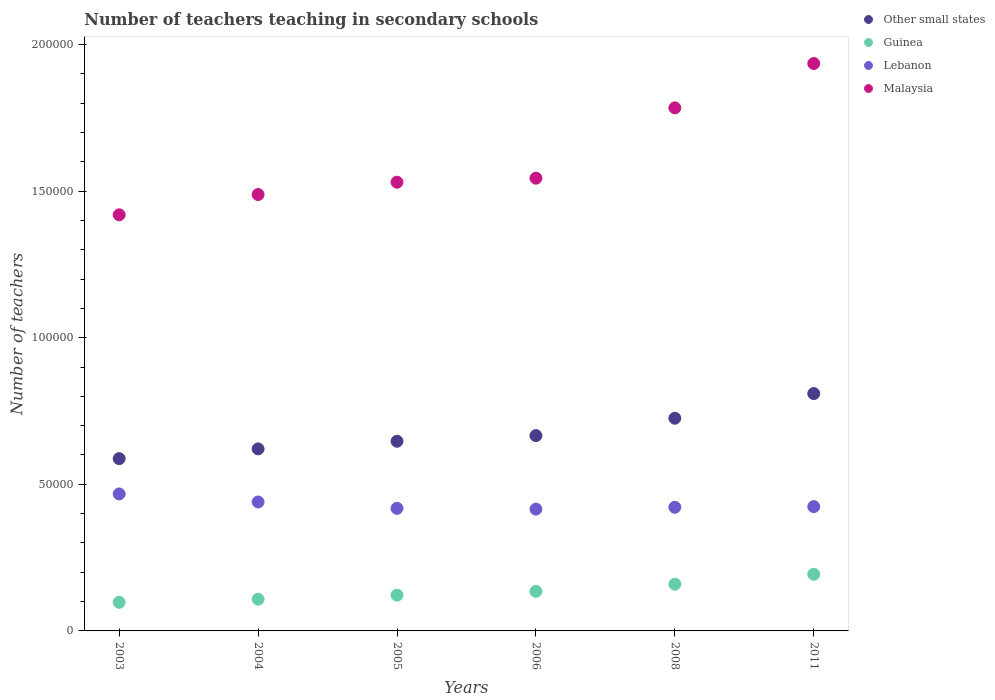How many different coloured dotlines are there?
Offer a very short reply. 4. Is the number of dotlines equal to the number of legend labels?
Offer a very short reply. Yes. What is the number of teachers teaching in secondary schools in Guinea in 2008?
Provide a succinct answer. 1.59e+04. Across all years, what is the maximum number of teachers teaching in secondary schools in Lebanon?
Give a very brief answer. 4.67e+04. Across all years, what is the minimum number of teachers teaching in secondary schools in Malaysia?
Provide a short and direct response. 1.42e+05. In which year was the number of teachers teaching in secondary schools in Guinea minimum?
Offer a terse response. 2003. What is the total number of teachers teaching in secondary schools in Guinea in the graph?
Provide a succinct answer. 8.15e+04. What is the difference between the number of teachers teaching in secondary schools in Guinea in 2003 and that in 2005?
Give a very brief answer. -2445. What is the difference between the number of teachers teaching in secondary schools in Lebanon in 2006 and the number of teachers teaching in secondary schools in Malaysia in 2004?
Offer a very short reply. -1.07e+05. What is the average number of teachers teaching in secondary schools in Malaysia per year?
Offer a very short reply. 1.62e+05. In the year 2005, what is the difference between the number of teachers teaching in secondary schools in Guinea and number of teachers teaching in secondary schools in Other small states?
Your response must be concise. -5.25e+04. In how many years, is the number of teachers teaching in secondary schools in Guinea greater than 40000?
Provide a succinct answer. 0. What is the ratio of the number of teachers teaching in secondary schools in Other small states in 2004 to that in 2008?
Your answer should be compact. 0.86. Is the number of teachers teaching in secondary schools in Lebanon in 2005 less than that in 2011?
Provide a succinct answer. Yes. Is the difference between the number of teachers teaching in secondary schools in Guinea in 2005 and 2006 greater than the difference between the number of teachers teaching in secondary schools in Other small states in 2005 and 2006?
Keep it short and to the point. Yes. What is the difference between the highest and the second highest number of teachers teaching in secondary schools in Guinea?
Keep it short and to the point. 3381. What is the difference between the highest and the lowest number of teachers teaching in secondary schools in Other small states?
Keep it short and to the point. 2.22e+04. In how many years, is the number of teachers teaching in secondary schools in Guinea greater than the average number of teachers teaching in secondary schools in Guinea taken over all years?
Your answer should be very brief. 2. Is the number of teachers teaching in secondary schools in Malaysia strictly greater than the number of teachers teaching in secondary schools in Other small states over the years?
Offer a terse response. Yes. Is the number of teachers teaching in secondary schools in Lebanon strictly less than the number of teachers teaching in secondary schools in Other small states over the years?
Your answer should be compact. Yes. Does the graph contain any zero values?
Provide a short and direct response. No. How are the legend labels stacked?
Your response must be concise. Vertical. What is the title of the graph?
Your answer should be very brief. Number of teachers teaching in secondary schools. What is the label or title of the X-axis?
Ensure brevity in your answer.  Years. What is the label or title of the Y-axis?
Ensure brevity in your answer.  Number of teachers. What is the Number of teachers of Other small states in 2003?
Keep it short and to the point. 5.88e+04. What is the Number of teachers in Guinea in 2003?
Ensure brevity in your answer.  9757. What is the Number of teachers of Lebanon in 2003?
Give a very brief answer. 4.67e+04. What is the Number of teachers of Malaysia in 2003?
Keep it short and to the point. 1.42e+05. What is the Number of teachers of Other small states in 2004?
Offer a terse response. 6.21e+04. What is the Number of teachers of Guinea in 2004?
Keep it short and to the point. 1.08e+04. What is the Number of teachers of Lebanon in 2004?
Ensure brevity in your answer.  4.40e+04. What is the Number of teachers of Malaysia in 2004?
Offer a terse response. 1.49e+05. What is the Number of teachers in Other small states in 2005?
Ensure brevity in your answer.  6.47e+04. What is the Number of teachers of Guinea in 2005?
Give a very brief answer. 1.22e+04. What is the Number of teachers in Lebanon in 2005?
Your answer should be compact. 4.18e+04. What is the Number of teachers of Malaysia in 2005?
Ensure brevity in your answer.  1.53e+05. What is the Number of teachers of Other small states in 2006?
Make the answer very short. 6.66e+04. What is the Number of teachers of Guinea in 2006?
Give a very brief answer. 1.35e+04. What is the Number of teachers of Lebanon in 2006?
Ensure brevity in your answer.  4.15e+04. What is the Number of teachers of Malaysia in 2006?
Make the answer very short. 1.54e+05. What is the Number of teachers of Other small states in 2008?
Provide a short and direct response. 7.25e+04. What is the Number of teachers of Guinea in 2008?
Make the answer very short. 1.59e+04. What is the Number of teachers in Lebanon in 2008?
Make the answer very short. 4.22e+04. What is the Number of teachers of Malaysia in 2008?
Make the answer very short. 1.78e+05. What is the Number of teachers of Other small states in 2011?
Provide a succinct answer. 8.09e+04. What is the Number of teachers of Guinea in 2011?
Your answer should be very brief. 1.93e+04. What is the Number of teachers in Lebanon in 2011?
Offer a terse response. 4.24e+04. What is the Number of teachers of Malaysia in 2011?
Provide a short and direct response. 1.94e+05. Across all years, what is the maximum Number of teachers of Other small states?
Make the answer very short. 8.09e+04. Across all years, what is the maximum Number of teachers in Guinea?
Give a very brief answer. 1.93e+04. Across all years, what is the maximum Number of teachers in Lebanon?
Your response must be concise. 4.67e+04. Across all years, what is the maximum Number of teachers of Malaysia?
Your answer should be compact. 1.94e+05. Across all years, what is the minimum Number of teachers in Other small states?
Offer a terse response. 5.88e+04. Across all years, what is the minimum Number of teachers in Guinea?
Your answer should be very brief. 9757. Across all years, what is the minimum Number of teachers in Lebanon?
Ensure brevity in your answer.  4.15e+04. Across all years, what is the minimum Number of teachers in Malaysia?
Keep it short and to the point. 1.42e+05. What is the total Number of teachers in Other small states in the graph?
Give a very brief answer. 4.06e+05. What is the total Number of teachers in Guinea in the graph?
Your answer should be very brief. 8.15e+04. What is the total Number of teachers in Lebanon in the graph?
Keep it short and to the point. 2.59e+05. What is the total Number of teachers in Malaysia in the graph?
Give a very brief answer. 9.70e+05. What is the difference between the Number of teachers of Other small states in 2003 and that in 2004?
Offer a very short reply. -3322.16. What is the difference between the Number of teachers of Guinea in 2003 and that in 2004?
Keep it short and to the point. -1071. What is the difference between the Number of teachers of Lebanon in 2003 and that in 2004?
Provide a short and direct response. 2750. What is the difference between the Number of teachers in Malaysia in 2003 and that in 2004?
Your answer should be compact. -6911. What is the difference between the Number of teachers of Other small states in 2003 and that in 2005?
Ensure brevity in your answer.  -5920.92. What is the difference between the Number of teachers in Guinea in 2003 and that in 2005?
Your answer should be very brief. -2445. What is the difference between the Number of teachers of Lebanon in 2003 and that in 2005?
Provide a short and direct response. 4920. What is the difference between the Number of teachers of Malaysia in 2003 and that in 2005?
Keep it short and to the point. -1.11e+04. What is the difference between the Number of teachers in Other small states in 2003 and that in 2006?
Keep it short and to the point. -7842.73. What is the difference between the Number of teachers of Guinea in 2003 and that in 2006?
Give a very brief answer. -3720. What is the difference between the Number of teachers of Lebanon in 2003 and that in 2006?
Your answer should be compact. 5185. What is the difference between the Number of teachers of Malaysia in 2003 and that in 2006?
Provide a succinct answer. -1.25e+04. What is the difference between the Number of teachers in Other small states in 2003 and that in 2008?
Offer a very short reply. -1.38e+04. What is the difference between the Number of teachers in Guinea in 2003 and that in 2008?
Keep it short and to the point. -6184. What is the difference between the Number of teachers of Lebanon in 2003 and that in 2008?
Provide a short and direct response. 4556. What is the difference between the Number of teachers in Malaysia in 2003 and that in 2008?
Your answer should be compact. -3.65e+04. What is the difference between the Number of teachers of Other small states in 2003 and that in 2011?
Offer a terse response. -2.22e+04. What is the difference between the Number of teachers in Guinea in 2003 and that in 2011?
Keep it short and to the point. -9565. What is the difference between the Number of teachers in Lebanon in 2003 and that in 2011?
Your answer should be very brief. 4334. What is the difference between the Number of teachers in Malaysia in 2003 and that in 2011?
Offer a terse response. -5.16e+04. What is the difference between the Number of teachers of Other small states in 2004 and that in 2005?
Your response must be concise. -2598.76. What is the difference between the Number of teachers of Guinea in 2004 and that in 2005?
Give a very brief answer. -1374. What is the difference between the Number of teachers in Lebanon in 2004 and that in 2005?
Provide a short and direct response. 2170. What is the difference between the Number of teachers in Malaysia in 2004 and that in 2005?
Make the answer very short. -4207. What is the difference between the Number of teachers in Other small states in 2004 and that in 2006?
Offer a terse response. -4520.57. What is the difference between the Number of teachers of Guinea in 2004 and that in 2006?
Make the answer very short. -2649. What is the difference between the Number of teachers of Lebanon in 2004 and that in 2006?
Your response must be concise. 2435. What is the difference between the Number of teachers in Malaysia in 2004 and that in 2006?
Offer a very short reply. -5583. What is the difference between the Number of teachers in Other small states in 2004 and that in 2008?
Give a very brief answer. -1.05e+04. What is the difference between the Number of teachers in Guinea in 2004 and that in 2008?
Keep it short and to the point. -5113. What is the difference between the Number of teachers of Lebanon in 2004 and that in 2008?
Offer a terse response. 1806. What is the difference between the Number of teachers in Malaysia in 2004 and that in 2008?
Offer a terse response. -2.96e+04. What is the difference between the Number of teachers of Other small states in 2004 and that in 2011?
Your answer should be compact. -1.89e+04. What is the difference between the Number of teachers in Guinea in 2004 and that in 2011?
Your answer should be very brief. -8494. What is the difference between the Number of teachers of Lebanon in 2004 and that in 2011?
Offer a very short reply. 1584. What is the difference between the Number of teachers of Malaysia in 2004 and that in 2011?
Give a very brief answer. -4.47e+04. What is the difference between the Number of teachers in Other small states in 2005 and that in 2006?
Offer a very short reply. -1921.81. What is the difference between the Number of teachers in Guinea in 2005 and that in 2006?
Your answer should be very brief. -1275. What is the difference between the Number of teachers of Lebanon in 2005 and that in 2006?
Offer a terse response. 265. What is the difference between the Number of teachers of Malaysia in 2005 and that in 2006?
Offer a terse response. -1376. What is the difference between the Number of teachers in Other small states in 2005 and that in 2008?
Offer a terse response. -7857.45. What is the difference between the Number of teachers in Guinea in 2005 and that in 2008?
Provide a succinct answer. -3739. What is the difference between the Number of teachers of Lebanon in 2005 and that in 2008?
Offer a very short reply. -364. What is the difference between the Number of teachers of Malaysia in 2005 and that in 2008?
Your answer should be very brief. -2.53e+04. What is the difference between the Number of teachers of Other small states in 2005 and that in 2011?
Your answer should be very brief. -1.63e+04. What is the difference between the Number of teachers in Guinea in 2005 and that in 2011?
Your response must be concise. -7120. What is the difference between the Number of teachers in Lebanon in 2005 and that in 2011?
Offer a terse response. -586. What is the difference between the Number of teachers of Malaysia in 2005 and that in 2011?
Ensure brevity in your answer.  -4.05e+04. What is the difference between the Number of teachers in Other small states in 2006 and that in 2008?
Make the answer very short. -5935.64. What is the difference between the Number of teachers of Guinea in 2006 and that in 2008?
Give a very brief answer. -2464. What is the difference between the Number of teachers of Lebanon in 2006 and that in 2008?
Give a very brief answer. -629. What is the difference between the Number of teachers in Malaysia in 2006 and that in 2008?
Make the answer very short. -2.40e+04. What is the difference between the Number of teachers in Other small states in 2006 and that in 2011?
Make the answer very short. -1.43e+04. What is the difference between the Number of teachers of Guinea in 2006 and that in 2011?
Offer a very short reply. -5845. What is the difference between the Number of teachers of Lebanon in 2006 and that in 2011?
Offer a very short reply. -851. What is the difference between the Number of teachers of Malaysia in 2006 and that in 2011?
Make the answer very short. -3.91e+04. What is the difference between the Number of teachers in Other small states in 2008 and that in 2011?
Make the answer very short. -8408.55. What is the difference between the Number of teachers in Guinea in 2008 and that in 2011?
Provide a succinct answer. -3381. What is the difference between the Number of teachers of Lebanon in 2008 and that in 2011?
Keep it short and to the point. -222. What is the difference between the Number of teachers of Malaysia in 2008 and that in 2011?
Provide a succinct answer. -1.51e+04. What is the difference between the Number of teachers of Other small states in 2003 and the Number of teachers of Guinea in 2004?
Provide a succinct answer. 4.79e+04. What is the difference between the Number of teachers in Other small states in 2003 and the Number of teachers in Lebanon in 2004?
Keep it short and to the point. 1.48e+04. What is the difference between the Number of teachers in Other small states in 2003 and the Number of teachers in Malaysia in 2004?
Make the answer very short. -9.01e+04. What is the difference between the Number of teachers of Guinea in 2003 and the Number of teachers of Lebanon in 2004?
Offer a terse response. -3.42e+04. What is the difference between the Number of teachers in Guinea in 2003 and the Number of teachers in Malaysia in 2004?
Ensure brevity in your answer.  -1.39e+05. What is the difference between the Number of teachers of Lebanon in 2003 and the Number of teachers of Malaysia in 2004?
Your response must be concise. -1.02e+05. What is the difference between the Number of teachers in Other small states in 2003 and the Number of teachers in Guinea in 2005?
Ensure brevity in your answer.  4.66e+04. What is the difference between the Number of teachers in Other small states in 2003 and the Number of teachers in Lebanon in 2005?
Offer a very short reply. 1.70e+04. What is the difference between the Number of teachers in Other small states in 2003 and the Number of teachers in Malaysia in 2005?
Your answer should be very brief. -9.43e+04. What is the difference between the Number of teachers of Guinea in 2003 and the Number of teachers of Lebanon in 2005?
Ensure brevity in your answer.  -3.20e+04. What is the difference between the Number of teachers in Guinea in 2003 and the Number of teachers in Malaysia in 2005?
Provide a short and direct response. -1.43e+05. What is the difference between the Number of teachers of Lebanon in 2003 and the Number of teachers of Malaysia in 2005?
Your answer should be compact. -1.06e+05. What is the difference between the Number of teachers of Other small states in 2003 and the Number of teachers of Guinea in 2006?
Keep it short and to the point. 4.53e+04. What is the difference between the Number of teachers in Other small states in 2003 and the Number of teachers in Lebanon in 2006?
Give a very brief answer. 1.72e+04. What is the difference between the Number of teachers of Other small states in 2003 and the Number of teachers of Malaysia in 2006?
Offer a very short reply. -9.56e+04. What is the difference between the Number of teachers of Guinea in 2003 and the Number of teachers of Lebanon in 2006?
Your answer should be very brief. -3.18e+04. What is the difference between the Number of teachers in Guinea in 2003 and the Number of teachers in Malaysia in 2006?
Offer a terse response. -1.45e+05. What is the difference between the Number of teachers of Lebanon in 2003 and the Number of teachers of Malaysia in 2006?
Offer a very short reply. -1.08e+05. What is the difference between the Number of teachers of Other small states in 2003 and the Number of teachers of Guinea in 2008?
Make the answer very short. 4.28e+04. What is the difference between the Number of teachers in Other small states in 2003 and the Number of teachers in Lebanon in 2008?
Your answer should be very brief. 1.66e+04. What is the difference between the Number of teachers of Other small states in 2003 and the Number of teachers of Malaysia in 2008?
Your answer should be very brief. -1.20e+05. What is the difference between the Number of teachers in Guinea in 2003 and the Number of teachers in Lebanon in 2008?
Offer a terse response. -3.24e+04. What is the difference between the Number of teachers in Guinea in 2003 and the Number of teachers in Malaysia in 2008?
Your response must be concise. -1.69e+05. What is the difference between the Number of teachers in Lebanon in 2003 and the Number of teachers in Malaysia in 2008?
Give a very brief answer. -1.32e+05. What is the difference between the Number of teachers of Other small states in 2003 and the Number of teachers of Guinea in 2011?
Your answer should be compact. 3.94e+04. What is the difference between the Number of teachers of Other small states in 2003 and the Number of teachers of Lebanon in 2011?
Offer a very short reply. 1.64e+04. What is the difference between the Number of teachers in Other small states in 2003 and the Number of teachers in Malaysia in 2011?
Ensure brevity in your answer.  -1.35e+05. What is the difference between the Number of teachers in Guinea in 2003 and the Number of teachers in Lebanon in 2011?
Your response must be concise. -3.26e+04. What is the difference between the Number of teachers in Guinea in 2003 and the Number of teachers in Malaysia in 2011?
Make the answer very short. -1.84e+05. What is the difference between the Number of teachers of Lebanon in 2003 and the Number of teachers of Malaysia in 2011?
Give a very brief answer. -1.47e+05. What is the difference between the Number of teachers in Other small states in 2004 and the Number of teachers in Guinea in 2005?
Your response must be concise. 4.99e+04. What is the difference between the Number of teachers of Other small states in 2004 and the Number of teachers of Lebanon in 2005?
Offer a very short reply. 2.03e+04. What is the difference between the Number of teachers in Other small states in 2004 and the Number of teachers in Malaysia in 2005?
Your response must be concise. -9.10e+04. What is the difference between the Number of teachers of Guinea in 2004 and the Number of teachers of Lebanon in 2005?
Give a very brief answer. -3.10e+04. What is the difference between the Number of teachers of Guinea in 2004 and the Number of teachers of Malaysia in 2005?
Provide a succinct answer. -1.42e+05. What is the difference between the Number of teachers of Lebanon in 2004 and the Number of teachers of Malaysia in 2005?
Make the answer very short. -1.09e+05. What is the difference between the Number of teachers in Other small states in 2004 and the Number of teachers in Guinea in 2006?
Offer a very short reply. 4.86e+04. What is the difference between the Number of teachers of Other small states in 2004 and the Number of teachers of Lebanon in 2006?
Offer a terse response. 2.05e+04. What is the difference between the Number of teachers of Other small states in 2004 and the Number of teachers of Malaysia in 2006?
Make the answer very short. -9.23e+04. What is the difference between the Number of teachers of Guinea in 2004 and the Number of teachers of Lebanon in 2006?
Provide a succinct answer. -3.07e+04. What is the difference between the Number of teachers in Guinea in 2004 and the Number of teachers in Malaysia in 2006?
Offer a terse response. -1.44e+05. What is the difference between the Number of teachers of Lebanon in 2004 and the Number of teachers of Malaysia in 2006?
Your response must be concise. -1.10e+05. What is the difference between the Number of teachers in Other small states in 2004 and the Number of teachers in Guinea in 2008?
Ensure brevity in your answer.  4.61e+04. What is the difference between the Number of teachers of Other small states in 2004 and the Number of teachers of Lebanon in 2008?
Offer a terse response. 1.99e+04. What is the difference between the Number of teachers in Other small states in 2004 and the Number of teachers in Malaysia in 2008?
Make the answer very short. -1.16e+05. What is the difference between the Number of teachers in Guinea in 2004 and the Number of teachers in Lebanon in 2008?
Ensure brevity in your answer.  -3.13e+04. What is the difference between the Number of teachers in Guinea in 2004 and the Number of teachers in Malaysia in 2008?
Provide a succinct answer. -1.68e+05. What is the difference between the Number of teachers of Lebanon in 2004 and the Number of teachers of Malaysia in 2008?
Offer a very short reply. -1.34e+05. What is the difference between the Number of teachers of Other small states in 2004 and the Number of teachers of Guinea in 2011?
Your answer should be very brief. 4.28e+04. What is the difference between the Number of teachers in Other small states in 2004 and the Number of teachers in Lebanon in 2011?
Your answer should be compact. 1.97e+04. What is the difference between the Number of teachers of Other small states in 2004 and the Number of teachers of Malaysia in 2011?
Provide a short and direct response. -1.31e+05. What is the difference between the Number of teachers in Guinea in 2004 and the Number of teachers in Lebanon in 2011?
Keep it short and to the point. -3.16e+04. What is the difference between the Number of teachers in Guinea in 2004 and the Number of teachers in Malaysia in 2011?
Provide a succinct answer. -1.83e+05. What is the difference between the Number of teachers in Lebanon in 2004 and the Number of teachers in Malaysia in 2011?
Make the answer very short. -1.50e+05. What is the difference between the Number of teachers in Other small states in 2005 and the Number of teachers in Guinea in 2006?
Offer a very short reply. 5.12e+04. What is the difference between the Number of teachers of Other small states in 2005 and the Number of teachers of Lebanon in 2006?
Keep it short and to the point. 2.31e+04. What is the difference between the Number of teachers in Other small states in 2005 and the Number of teachers in Malaysia in 2006?
Provide a succinct answer. -8.97e+04. What is the difference between the Number of teachers of Guinea in 2005 and the Number of teachers of Lebanon in 2006?
Your answer should be compact. -2.93e+04. What is the difference between the Number of teachers of Guinea in 2005 and the Number of teachers of Malaysia in 2006?
Provide a succinct answer. -1.42e+05. What is the difference between the Number of teachers in Lebanon in 2005 and the Number of teachers in Malaysia in 2006?
Your response must be concise. -1.13e+05. What is the difference between the Number of teachers in Other small states in 2005 and the Number of teachers in Guinea in 2008?
Offer a terse response. 4.87e+04. What is the difference between the Number of teachers of Other small states in 2005 and the Number of teachers of Lebanon in 2008?
Keep it short and to the point. 2.25e+04. What is the difference between the Number of teachers of Other small states in 2005 and the Number of teachers of Malaysia in 2008?
Offer a terse response. -1.14e+05. What is the difference between the Number of teachers of Guinea in 2005 and the Number of teachers of Lebanon in 2008?
Keep it short and to the point. -3.00e+04. What is the difference between the Number of teachers of Guinea in 2005 and the Number of teachers of Malaysia in 2008?
Your response must be concise. -1.66e+05. What is the difference between the Number of teachers of Lebanon in 2005 and the Number of teachers of Malaysia in 2008?
Your response must be concise. -1.37e+05. What is the difference between the Number of teachers in Other small states in 2005 and the Number of teachers in Guinea in 2011?
Your answer should be very brief. 4.54e+04. What is the difference between the Number of teachers of Other small states in 2005 and the Number of teachers of Lebanon in 2011?
Provide a succinct answer. 2.23e+04. What is the difference between the Number of teachers in Other small states in 2005 and the Number of teachers in Malaysia in 2011?
Your answer should be compact. -1.29e+05. What is the difference between the Number of teachers of Guinea in 2005 and the Number of teachers of Lebanon in 2011?
Keep it short and to the point. -3.02e+04. What is the difference between the Number of teachers in Guinea in 2005 and the Number of teachers in Malaysia in 2011?
Offer a terse response. -1.81e+05. What is the difference between the Number of teachers of Lebanon in 2005 and the Number of teachers of Malaysia in 2011?
Provide a succinct answer. -1.52e+05. What is the difference between the Number of teachers in Other small states in 2006 and the Number of teachers in Guinea in 2008?
Make the answer very short. 5.07e+04. What is the difference between the Number of teachers of Other small states in 2006 and the Number of teachers of Lebanon in 2008?
Provide a succinct answer. 2.44e+04. What is the difference between the Number of teachers of Other small states in 2006 and the Number of teachers of Malaysia in 2008?
Provide a short and direct response. -1.12e+05. What is the difference between the Number of teachers in Guinea in 2006 and the Number of teachers in Lebanon in 2008?
Offer a terse response. -2.87e+04. What is the difference between the Number of teachers of Guinea in 2006 and the Number of teachers of Malaysia in 2008?
Offer a terse response. -1.65e+05. What is the difference between the Number of teachers of Lebanon in 2006 and the Number of teachers of Malaysia in 2008?
Keep it short and to the point. -1.37e+05. What is the difference between the Number of teachers of Other small states in 2006 and the Number of teachers of Guinea in 2011?
Ensure brevity in your answer.  4.73e+04. What is the difference between the Number of teachers in Other small states in 2006 and the Number of teachers in Lebanon in 2011?
Keep it short and to the point. 2.42e+04. What is the difference between the Number of teachers of Other small states in 2006 and the Number of teachers of Malaysia in 2011?
Offer a terse response. -1.27e+05. What is the difference between the Number of teachers in Guinea in 2006 and the Number of teachers in Lebanon in 2011?
Make the answer very short. -2.89e+04. What is the difference between the Number of teachers of Guinea in 2006 and the Number of teachers of Malaysia in 2011?
Your response must be concise. -1.80e+05. What is the difference between the Number of teachers in Lebanon in 2006 and the Number of teachers in Malaysia in 2011?
Your response must be concise. -1.52e+05. What is the difference between the Number of teachers in Other small states in 2008 and the Number of teachers in Guinea in 2011?
Offer a terse response. 5.32e+04. What is the difference between the Number of teachers of Other small states in 2008 and the Number of teachers of Lebanon in 2011?
Ensure brevity in your answer.  3.01e+04. What is the difference between the Number of teachers of Other small states in 2008 and the Number of teachers of Malaysia in 2011?
Offer a very short reply. -1.21e+05. What is the difference between the Number of teachers of Guinea in 2008 and the Number of teachers of Lebanon in 2011?
Offer a terse response. -2.64e+04. What is the difference between the Number of teachers of Guinea in 2008 and the Number of teachers of Malaysia in 2011?
Keep it short and to the point. -1.78e+05. What is the difference between the Number of teachers of Lebanon in 2008 and the Number of teachers of Malaysia in 2011?
Provide a succinct answer. -1.51e+05. What is the average Number of teachers of Other small states per year?
Provide a short and direct response. 6.76e+04. What is the average Number of teachers in Guinea per year?
Offer a terse response. 1.36e+04. What is the average Number of teachers in Lebanon per year?
Make the answer very short. 4.31e+04. What is the average Number of teachers in Malaysia per year?
Keep it short and to the point. 1.62e+05. In the year 2003, what is the difference between the Number of teachers in Other small states and Number of teachers in Guinea?
Give a very brief answer. 4.90e+04. In the year 2003, what is the difference between the Number of teachers in Other small states and Number of teachers in Lebanon?
Provide a succinct answer. 1.20e+04. In the year 2003, what is the difference between the Number of teachers of Other small states and Number of teachers of Malaysia?
Provide a succinct answer. -8.32e+04. In the year 2003, what is the difference between the Number of teachers in Guinea and Number of teachers in Lebanon?
Offer a very short reply. -3.70e+04. In the year 2003, what is the difference between the Number of teachers of Guinea and Number of teachers of Malaysia?
Provide a short and direct response. -1.32e+05. In the year 2003, what is the difference between the Number of teachers in Lebanon and Number of teachers in Malaysia?
Make the answer very short. -9.52e+04. In the year 2004, what is the difference between the Number of teachers of Other small states and Number of teachers of Guinea?
Provide a short and direct response. 5.13e+04. In the year 2004, what is the difference between the Number of teachers in Other small states and Number of teachers in Lebanon?
Keep it short and to the point. 1.81e+04. In the year 2004, what is the difference between the Number of teachers in Other small states and Number of teachers in Malaysia?
Your response must be concise. -8.67e+04. In the year 2004, what is the difference between the Number of teachers of Guinea and Number of teachers of Lebanon?
Give a very brief answer. -3.31e+04. In the year 2004, what is the difference between the Number of teachers of Guinea and Number of teachers of Malaysia?
Keep it short and to the point. -1.38e+05. In the year 2004, what is the difference between the Number of teachers of Lebanon and Number of teachers of Malaysia?
Provide a succinct answer. -1.05e+05. In the year 2005, what is the difference between the Number of teachers of Other small states and Number of teachers of Guinea?
Ensure brevity in your answer.  5.25e+04. In the year 2005, what is the difference between the Number of teachers of Other small states and Number of teachers of Lebanon?
Keep it short and to the point. 2.29e+04. In the year 2005, what is the difference between the Number of teachers of Other small states and Number of teachers of Malaysia?
Your answer should be very brief. -8.84e+04. In the year 2005, what is the difference between the Number of teachers in Guinea and Number of teachers in Lebanon?
Your response must be concise. -2.96e+04. In the year 2005, what is the difference between the Number of teachers in Guinea and Number of teachers in Malaysia?
Make the answer very short. -1.41e+05. In the year 2005, what is the difference between the Number of teachers of Lebanon and Number of teachers of Malaysia?
Provide a short and direct response. -1.11e+05. In the year 2006, what is the difference between the Number of teachers of Other small states and Number of teachers of Guinea?
Keep it short and to the point. 5.31e+04. In the year 2006, what is the difference between the Number of teachers of Other small states and Number of teachers of Lebanon?
Make the answer very short. 2.51e+04. In the year 2006, what is the difference between the Number of teachers in Other small states and Number of teachers in Malaysia?
Provide a short and direct response. -8.78e+04. In the year 2006, what is the difference between the Number of teachers of Guinea and Number of teachers of Lebanon?
Offer a terse response. -2.81e+04. In the year 2006, what is the difference between the Number of teachers in Guinea and Number of teachers in Malaysia?
Offer a terse response. -1.41e+05. In the year 2006, what is the difference between the Number of teachers in Lebanon and Number of teachers in Malaysia?
Your response must be concise. -1.13e+05. In the year 2008, what is the difference between the Number of teachers of Other small states and Number of teachers of Guinea?
Offer a terse response. 5.66e+04. In the year 2008, what is the difference between the Number of teachers of Other small states and Number of teachers of Lebanon?
Your answer should be compact. 3.04e+04. In the year 2008, what is the difference between the Number of teachers in Other small states and Number of teachers in Malaysia?
Give a very brief answer. -1.06e+05. In the year 2008, what is the difference between the Number of teachers in Guinea and Number of teachers in Lebanon?
Ensure brevity in your answer.  -2.62e+04. In the year 2008, what is the difference between the Number of teachers of Guinea and Number of teachers of Malaysia?
Ensure brevity in your answer.  -1.62e+05. In the year 2008, what is the difference between the Number of teachers of Lebanon and Number of teachers of Malaysia?
Ensure brevity in your answer.  -1.36e+05. In the year 2011, what is the difference between the Number of teachers in Other small states and Number of teachers in Guinea?
Offer a very short reply. 6.16e+04. In the year 2011, what is the difference between the Number of teachers in Other small states and Number of teachers in Lebanon?
Your answer should be compact. 3.86e+04. In the year 2011, what is the difference between the Number of teachers of Other small states and Number of teachers of Malaysia?
Provide a succinct answer. -1.13e+05. In the year 2011, what is the difference between the Number of teachers in Guinea and Number of teachers in Lebanon?
Your answer should be very brief. -2.31e+04. In the year 2011, what is the difference between the Number of teachers in Guinea and Number of teachers in Malaysia?
Your answer should be very brief. -1.74e+05. In the year 2011, what is the difference between the Number of teachers of Lebanon and Number of teachers of Malaysia?
Offer a terse response. -1.51e+05. What is the ratio of the Number of teachers in Other small states in 2003 to that in 2004?
Provide a succinct answer. 0.95. What is the ratio of the Number of teachers of Guinea in 2003 to that in 2004?
Ensure brevity in your answer.  0.9. What is the ratio of the Number of teachers of Malaysia in 2003 to that in 2004?
Offer a very short reply. 0.95. What is the ratio of the Number of teachers in Other small states in 2003 to that in 2005?
Offer a terse response. 0.91. What is the ratio of the Number of teachers in Guinea in 2003 to that in 2005?
Ensure brevity in your answer.  0.8. What is the ratio of the Number of teachers of Lebanon in 2003 to that in 2005?
Provide a short and direct response. 1.12. What is the ratio of the Number of teachers in Malaysia in 2003 to that in 2005?
Provide a short and direct response. 0.93. What is the ratio of the Number of teachers in Other small states in 2003 to that in 2006?
Your answer should be compact. 0.88. What is the ratio of the Number of teachers in Guinea in 2003 to that in 2006?
Your response must be concise. 0.72. What is the ratio of the Number of teachers in Lebanon in 2003 to that in 2006?
Your response must be concise. 1.12. What is the ratio of the Number of teachers of Malaysia in 2003 to that in 2006?
Ensure brevity in your answer.  0.92. What is the ratio of the Number of teachers in Other small states in 2003 to that in 2008?
Offer a terse response. 0.81. What is the ratio of the Number of teachers in Guinea in 2003 to that in 2008?
Your answer should be very brief. 0.61. What is the ratio of the Number of teachers of Lebanon in 2003 to that in 2008?
Make the answer very short. 1.11. What is the ratio of the Number of teachers in Malaysia in 2003 to that in 2008?
Your answer should be very brief. 0.8. What is the ratio of the Number of teachers in Other small states in 2003 to that in 2011?
Your answer should be very brief. 0.73. What is the ratio of the Number of teachers in Guinea in 2003 to that in 2011?
Your answer should be very brief. 0.51. What is the ratio of the Number of teachers of Lebanon in 2003 to that in 2011?
Make the answer very short. 1.1. What is the ratio of the Number of teachers in Malaysia in 2003 to that in 2011?
Your response must be concise. 0.73. What is the ratio of the Number of teachers of Other small states in 2004 to that in 2005?
Provide a short and direct response. 0.96. What is the ratio of the Number of teachers of Guinea in 2004 to that in 2005?
Provide a succinct answer. 0.89. What is the ratio of the Number of teachers in Lebanon in 2004 to that in 2005?
Your answer should be very brief. 1.05. What is the ratio of the Number of teachers of Malaysia in 2004 to that in 2005?
Keep it short and to the point. 0.97. What is the ratio of the Number of teachers in Other small states in 2004 to that in 2006?
Your answer should be very brief. 0.93. What is the ratio of the Number of teachers in Guinea in 2004 to that in 2006?
Your answer should be very brief. 0.8. What is the ratio of the Number of teachers of Lebanon in 2004 to that in 2006?
Provide a succinct answer. 1.06. What is the ratio of the Number of teachers of Malaysia in 2004 to that in 2006?
Ensure brevity in your answer.  0.96. What is the ratio of the Number of teachers of Other small states in 2004 to that in 2008?
Offer a terse response. 0.86. What is the ratio of the Number of teachers in Guinea in 2004 to that in 2008?
Make the answer very short. 0.68. What is the ratio of the Number of teachers of Lebanon in 2004 to that in 2008?
Give a very brief answer. 1.04. What is the ratio of the Number of teachers in Malaysia in 2004 to that in 2008?
Give a very brief answer. 0.83. What is the ratio of the Number of teachers in Other small states in 2004 to that in 2011?
Provide a succinct answer. 0.77. What is the ratio of the Number of teachers in Guinea in 2004 to that in 2011?
Ensure brevity in your answer.  0.56. What is the ratio of the Number of teachers in Lebanon in 2004 to that in 2011?
Your answer should be very brief. 1.04. What is the ratio of the Number of teachers in Malaysia in 2004 to that in 2011?
Keep it short and to the point. 0.77. What is the ratio of the Number of teachers of Other small states in 2005 to that in 2006?
Your answer should be compact. 0.97. What is the ratio of the Number of teachers in Guinea in 2005 to that in 2006?
Offer a very short reply. 0.91. What is the ratio of the Number of teachers in Lebanon in 2005 to that in 2006?
Give a very brief answer. 1.01. What is the ratio of the Number of teachers of Malaysia in 2005 to that in 2006?
Provide a short and direct response. 0.99. What is the ratio of the Number of teachers in Other small states in 2005 to that in 2008?
Your response must be concise. 0.89. What is the ratio of the Number of teachers in Guinea in 2005 to that in 2008?
Keep it short and to the point. 0.77. What is the ratio of the Number of teachers of Malaysia in 2005 to that in 2008?
Offer a very short reply. 0.86. What is the ratio of the Number of teachers of Other small states in 2005 to that in 2011?
Make the answer very short. 0.8. What is the ratio of the Number of teachers in Guinea in 2005 to that in 2011?
Your response must be concise. 0.63. What is the ratio of the Number of teachers in Lebanon in 2005 to that in 2011?
Your answer should be very brief. 0.99. What is the ratio of the Number of teachers in Malaysia in 2005 to that in 2011?
Your answer should be very brief. 0.79. What is the ratio of the Number of teachers of Other small states in 2006 to that in 2008?
Provide a succinct answer. 0.92. What is the ratio of the Number of teachers in Guinea in 2006 to that in 2008?
Offer a terse response. 0.85. What is the ratio of the Number of teachers of Lebanon in 2006 to that in 2008?
Provide a succinct answer. 0.99. What is the ratio of the Number of teachers in Malaysia in 2006 to that in 2008?
Make the answer very short. 0.87. What is the ratio of the Number of teachers of Other small states in 2006 to that in 2011?
Your response must be concise. 0.82. What is the ratio of the Number of teachers in Guinea in 2006 to that in 2011?
Provide a short and direct response. 0.7. What is the ratio of the Number of teachers of Lebanon in 2006 to that in 2011?
Give a very brief answer. 0.98. What is the ratio of the Number of teachers in Malaysia in 2006 to that in 2011?
Your answer should be compact. 0.8. What is the ratio of the Number of teachers in Other small states in 2008 to that in 2011?
Your answer should be very brief. 0.9. What is the ratio of the Number of teachers in Guinea in 2008 to that in 2011?
Provide a short and direct response. 0.82. What is the ratio of the Number of teachers of Malaysia in 2008 to that in 2011?
Make the answer very short. 0.92. What is the difference between the highest and the second highest Number of teachers of Other small states?
Keep it short and to the point. 8408.55. What is the difference between the highest and the second highest Number of teachers of Guinea?
Keep it short and to the point. 3381. What is the difference between the highest and the second highest Number of teachers of Lebanon?
Give a very brief answer. 2750. What is the difference between the highest and the second highest Number of teachers in Malaysia?
Provide a short and direct response. 1.51e+04. What is the difference between the highest and the lowest Number of teachers of Other small states?
Your answer should be compact. 2.22e+04. What is the difference between the highest and the lowest Number of teachers of Guinea?
Keep it short and to the point. 9565. What is the difference between the highest and the lowest Number of teachers of Lebanon?
Provide a short and direct response. 5185. What is the difference between the highest and the lowest Number of teachers in Malaysia?
Give a very brief answer. 5.16e+04. 